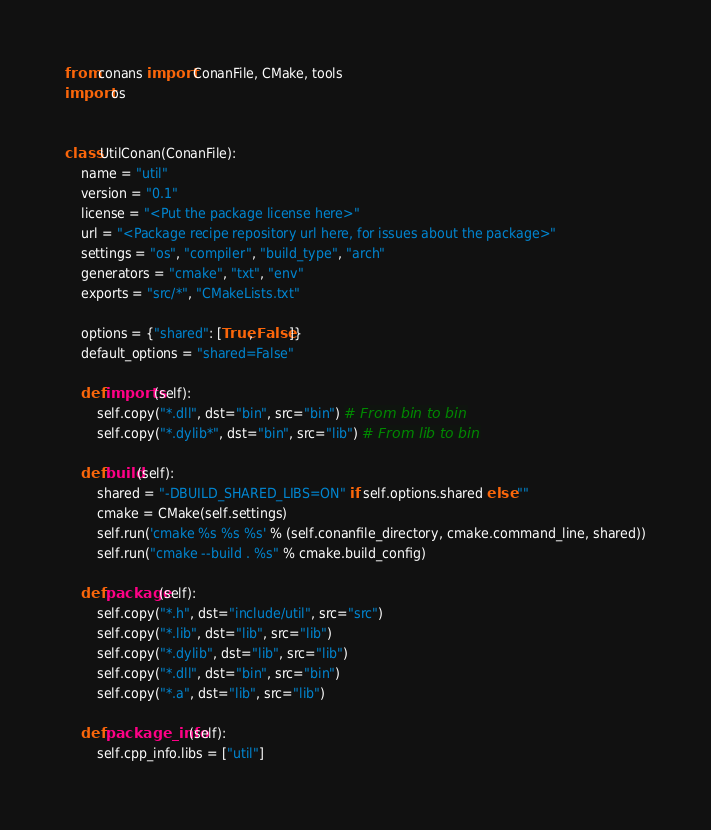Convert code to text. <code><loc_0><loc_0><loc_500><loc_500><_Python_>from conans import ConanFile, CMake, tools
import os


class UtilConan(ConanFile):
    name = "util"
    version = "0.1"
    license = "<Put the package license here>"
    url = "<Package recipe repository url here, for issues about the package>"
    settings = "os", "compiler", "build_type", "arch"
    generators = "cmake", "txt", "env"
    exports = "src/*", "CMakeLists.txt"

    options = {"shared": [True, False]}
    default_options = "shared=False"

    def imports(self):
        self.copy("*.dll", dst="bin", src="bin") # From bin to bin
        self.copy("*.dylib*", dst="bin", src="lib") # From lib to bin

    def build(self):
        shared = "-DBUILD_SHARED_LIBS=ON" if self.options.shared else ""
        cmake = CMake(self.settings)
        self.run('cmake %s %s %s' % (self.conanfile_directory, cmake.command_line, shared))
        self.run("cmake --build . %s" % cmake.build_config)

    def package(self):
        self.copy("*.h", dst="include/util", src="src")
        self.copy("*.lib", dst="lib", src="lib")
        self.copy("*.dylib", dst="lib", src="lib")
        self.copy("*.dll", dst="bin", src="bin")
        self.copy("*.a", dst="lib", src="lib")

    def package_info(self):
        self.cpp_info.libs = ["util"] 
</code> 